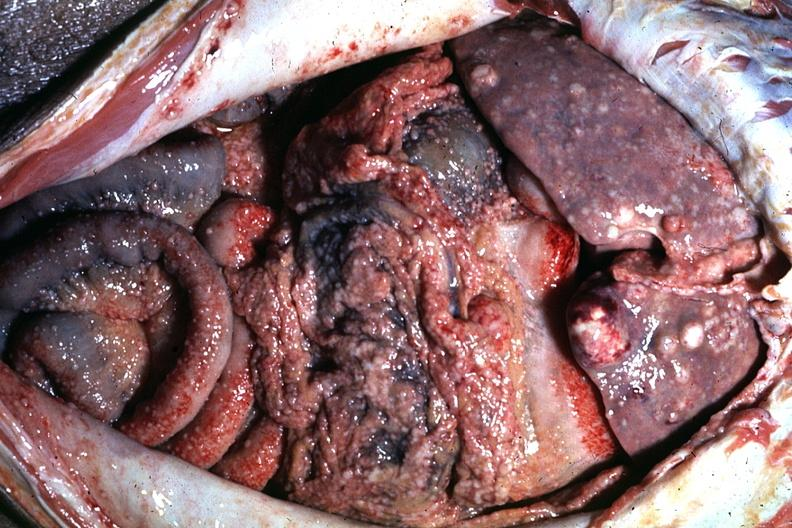what is present?
Answer the question using a single word or phrase. Metastatic carcinoma 